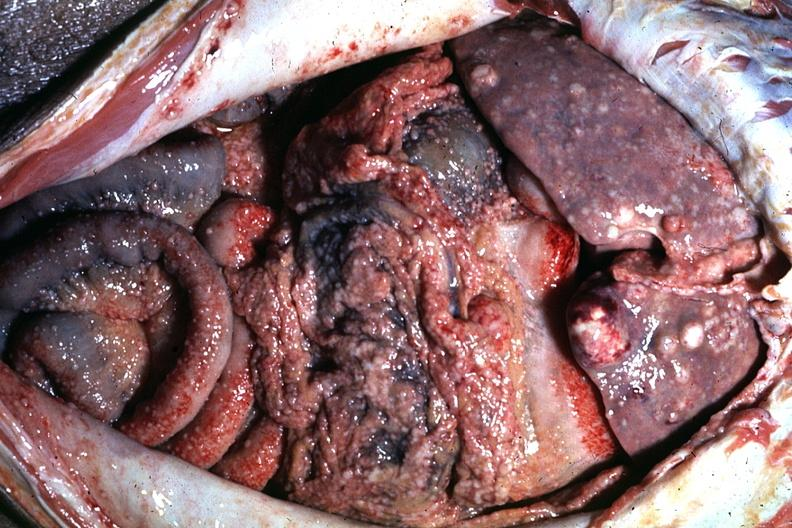what is present?
Answer the question using a single word or phrase. Metastatic carcinoma 